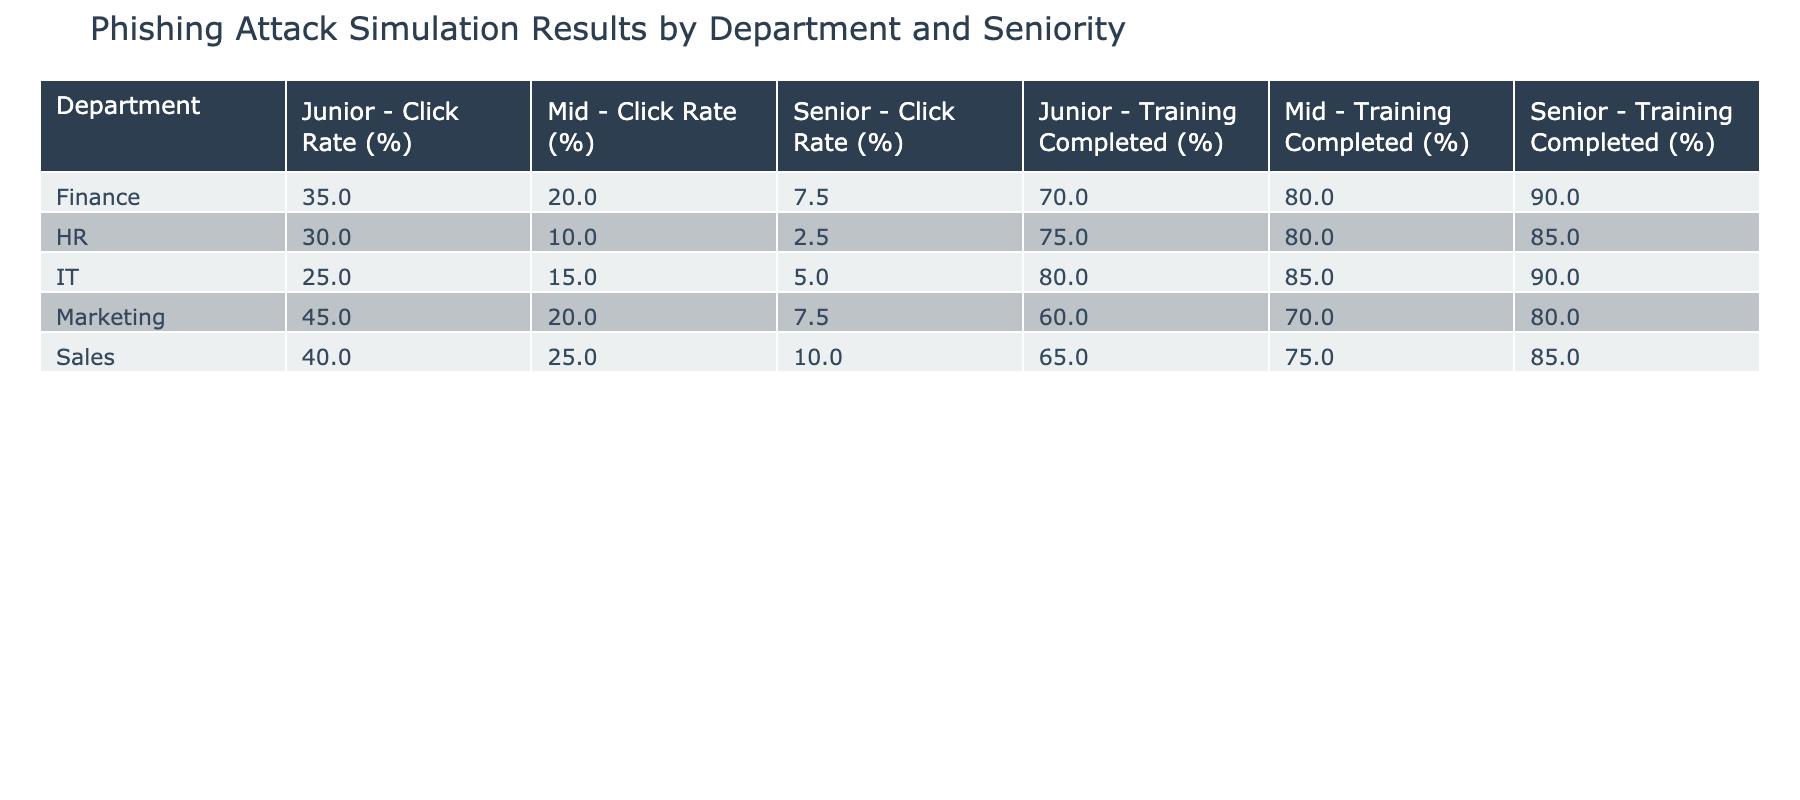What is the click rate for Senior employees in the HR department? According to the table, the HR department's Senior employees have a Click Rate of 2.5%. This value is directly taken from the corresponding cell in the "Click Rate (%)" column for HR Senior.
Answer: 2.5% What is the highest click rate among all departments? The highest click rate is found by scanning through all Click Rate values. The Marketing Junior position has the highest at 45%, which is directly listed in the table.
Answer: 45% Which department has the lowest click rate for Junior employees? To determine this, we compare the Click Rates for Junior employees across all departments: IT (25%), HR (30%), Finance (35%), Sales (40%), and Marketing (45%). The IT department has the lowest rate at 25%.
Answer: IT What is the average training completion percentage for Mid-level employees? To calculate this, we take the Training Completed percentages for Mid-level employees: IT (85%), HR (80%), Finance (80%), Sales (75%), and Marketing (70%). The average is (85 + 80 + 80 + 75 + 70) / 5 = 76%.
Answer: 76% Is the click rate for Junior employees in the Sales department higher than that in the Finance department? The click rate for Sales Junior employees is 40%, while for Finance Junior employees it is 35%. Since 40% (Sales) is greater than 35% (Finance), we can say yes.
Answer: Yes Which Senior level has the highest Training Completed percentage in the Finance department? Looking at the Training Completed percentages for Senior employees in the Finance department, it is 90%, which is the highest result for that department across all seniority levels.
Answer: 90% For which department is the difference in click rate between Junior and Senior employees the largest? We calculate the differences: IT (25% - 5% = 20%), HR (30% - 2.5% = 27.5%), Finance (35% - 7.5% = 27.5%), Sales (40% - 10% = 30%), and Marketing (45% - 7.5% = 37.5%). The largest difference is in Marketing at 37.5%.
Answer: Marketing Are there any departments where the Training Completed percentage for Junior employees is lower than 70%? By checking the Training Completed percentages for Junior employees, we find that the Sales department is at 65% and Marketing at 60%. Therefore, both these departments have percentages lower than 70%.
Answer: Yes 